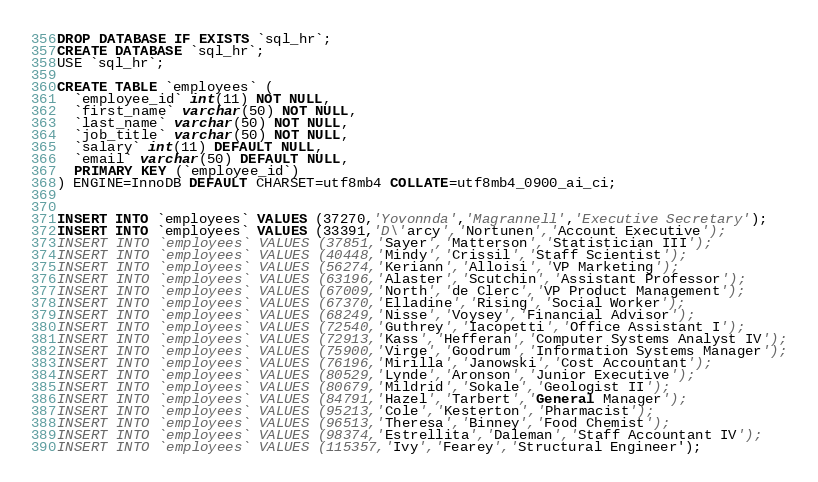<code> <loc_0><loc_0><loc_500><loc_500><_SQL_>DROP DATABASE IF EXISTS `sql_hr`;
CREATE DATABASE `sql_hr`;
USE `sql_hr`;

CREATE TABLE `employees` (
  `employee_id` int(11) NOT NULL,
  `first_name` varchar(50) NOT NULL,
  `last_name` varchar(50) NOT NULL,
  `job_title` varchar(50) NOT NULL,
  `salary` int(11) DEFAULT NULL,
  `email` varchar(50) DEFAULT NULL,
  PRIMARY KEY (`employee_id`)
) ENGINE=InnoDB DEFAULT CHARSET=utf8mb4 COLLATE=utf8mb4_0900_ai_ci;


INSERT INTO `employees` VALUES (37270,'Yovonnda','Magrannell','Executive Secretary');
INSERT INTO `employees` VALUES (33391,'D\'arcy','Nortunen','Account Executive');
INSERT INTO `employees` VALUES (37851,'Sayer','Matterson','Statistician III');
INSERT INTO `employees` VALUES (40448,'Mindy','Crissil','Staff Scientist');
INSERT INTO `employees` VALUES (56274,'Keriann','Alloisi','VP Marketing');
INSERT INTO `employees` VALUES (63196,'Alaster','Scutchin','Assistant Professor');
INSERT INTO `employees` VALUES (67009,'North','de Clerc','VP Product Management');
INSERT INTO `employees` VALUES (67370,'Elladine','Rising','Social Worker');
INSERT INTO `employees` VALUES (68249,'Nisse','Voysey','Financial Advisor');
INSERT INTO `employees` VALUES (72540,'Guthrey','Iacopetti','Office Assistant I');
INSERT INTO `employees` VALUES (72913,'Kass','Hefferan','Computer Systems Analyst IV');
INSERT INTO `employees` VALUES (75900,'Virge','Goodrum','Information Systems Manager');
INSERT INTO `employees` VALUES (76196,'Mirilla','Janowski','Cost Accountant');
INSERT INTO `employees` VALUES (80529,'Lynde','Aronson','Junior Executive');
INSERT INTO `employees` VALUES (80679,'Mildrid','Sokale','Geologist II');
INSERT INTO `employees` VALUES (84791,'Hazel','Tarbert','General Manager');
INSERT INTO `employees` VALUES (95213,'Cole','Kesterton','Pharmacist');
INSERT INTO `employees` VALUES (96513,'Theresa','Binney','Food Chemist');
INSERT INTO `employees` VALUES (98374,'Estrellita','Daleman','Staff Accountant IV');
INSERT INTO `employees` VALUES (115357,'Ivy','Fearey','Structural Engineer');



</code> 